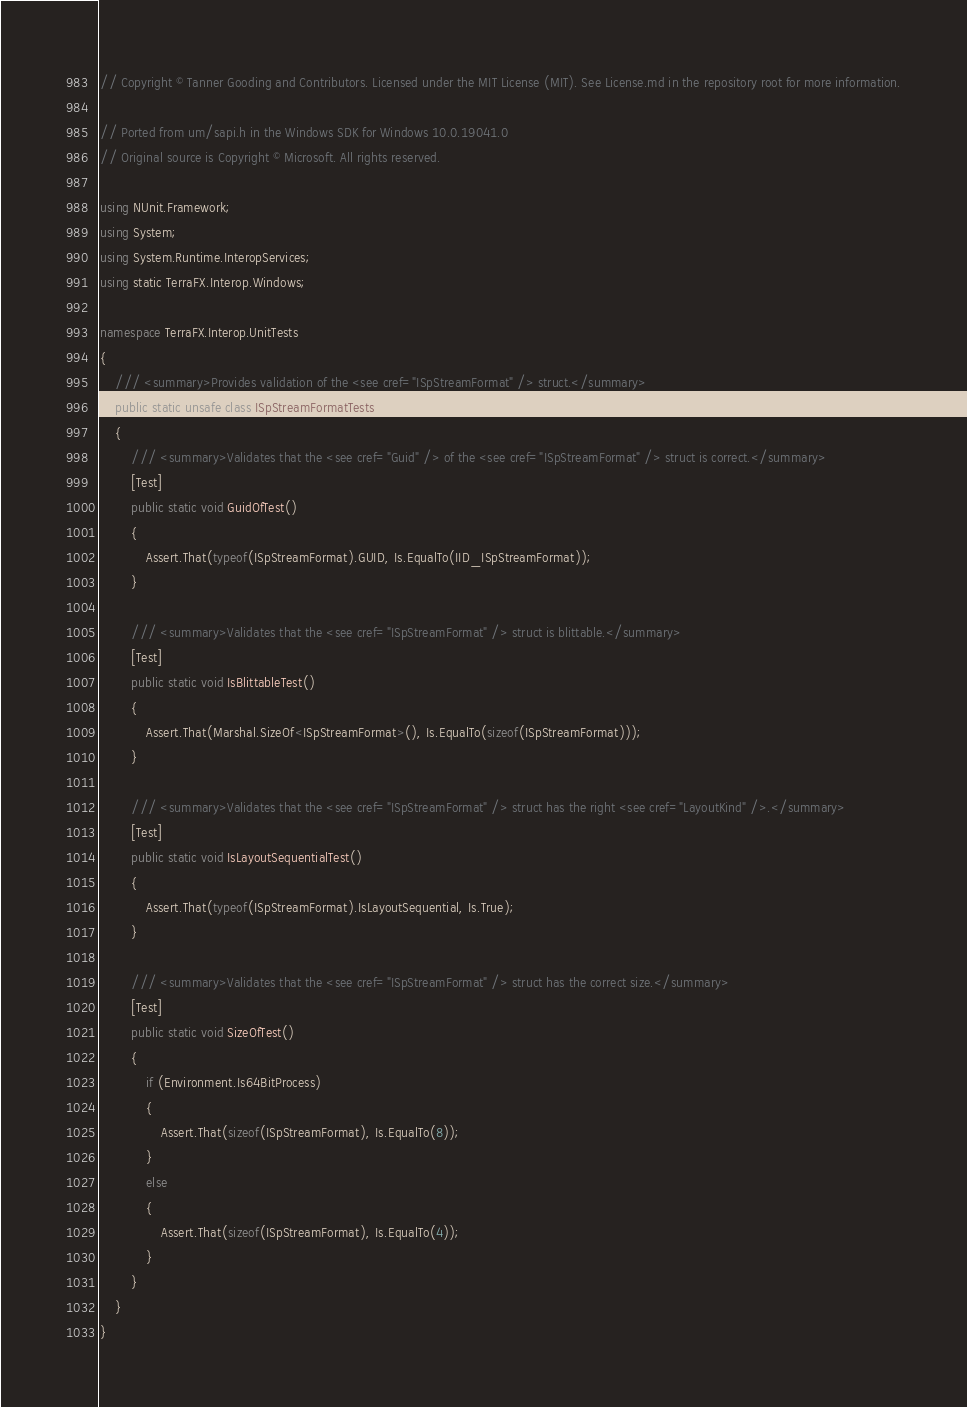Convert code to text. <code><loc_0><loc_0><loc_500><loc_500><_C#_>// Copyright © Tanner Gooding and Contributors. Licensed under the MIT License (MIT). See License.md in the repository root for more information.

// Ported from um/sapi.h in the Windows SDK for Windows 10.0.19041.0
// Original source is Copyright © Microsoft. All rights reserved.

using NUnit.Framework;
using System;
using System.Runtime.InteropServices;
using static TerraFX.Interop.Windows;

namespace TerraFX.Interop.UnitTests
{
    /// <summary>Provides validation of the <see cref="ISpStreamFormat" /> struct.</summary>
    public static unsafe class ISpStreamFormatTests
    {
        /// <summary>Validates that the <see cref="Guid" /> of the <see cref="ISpStreamFormat" /> struct is correct.</summary>
        [Test]
        public static void GuidOfTest()
        {
            Assert.That(typeof(ISpStreamFormat).GUID, Is.EqualTo(IID_ISpStreamFormat));
        }

        /// <summary>Validates that the <see cref="ISpStreamFormat" /> struct is blittable.</summary>
        [Test]
        public static void IsBlittableTest()
        {
            Assert.That(Marshal.SizeOf<ISpStreamFormat>(), Is.EqualTo(sizeof(ISpStreamFormat)));
        }

        /// <summary>Validates that the <see cref="ISpStreamFormat" /> struct has the right <see cref="LayoutKind" />.</summary>
        [Test]
        public static void IsLayoutSequentialTest()
        {
            Assert.That(typeof(ISpStreamFormat).IsLayoutSequential, Is.True);
        }

        /// <summary>Validates that the <see cref="ISpStreamFormat" /> struct has the correct size.</summary>
        [Test]
        public static void SizeOfTest()
        {
            if (Environment.Is64BitProcess)
            {
                Assert.That(sizeof(ISpStreamFormat), Is.EqualTo(8));
            }
            else
            {
                Assert.That(sizeof(ISpStreamFormat), Is.EqualTo(4));
            }
        }
    }
}
</code> 